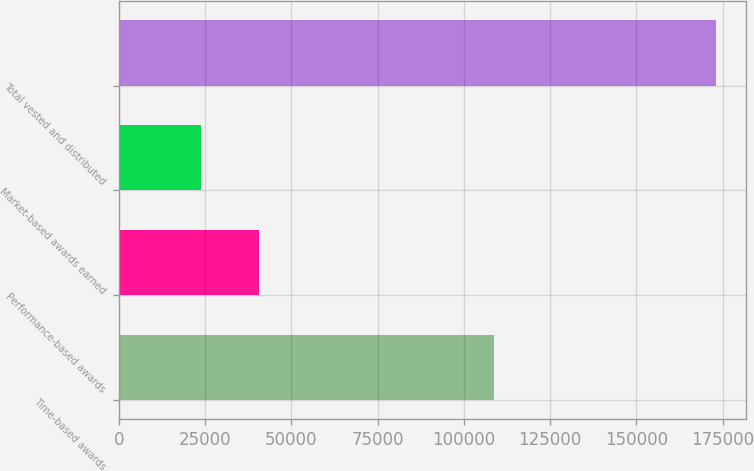Convert chart. <chart><loc_0><loc_0><loc_500><loc_500><bar_chart><fcel>Time-based awards<fcel>Performance-based awards<fcel>Market-based awards earned<fcel>Total vested and distributed<nl><fcel>108637<fcel>40618<fcel>23821<fcel>173076<nl></chart> 